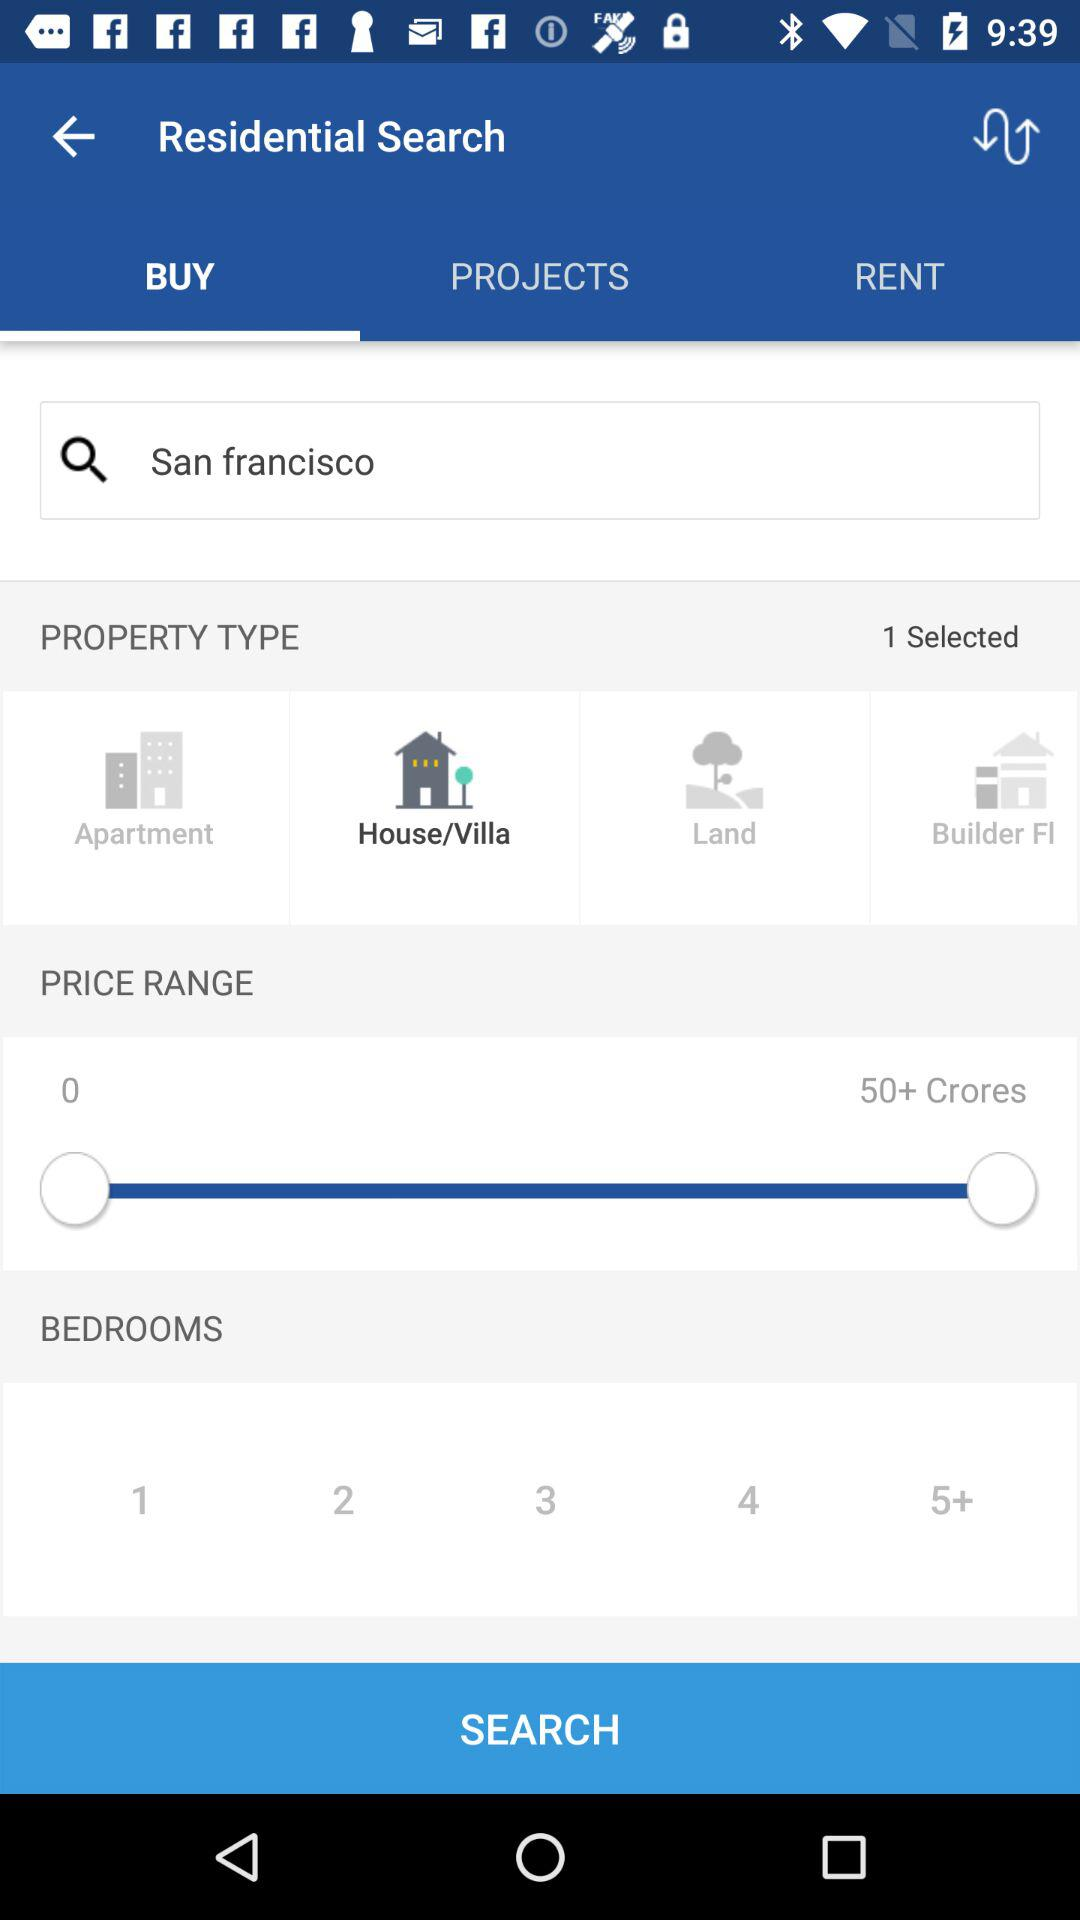What is the location inputted into the search bar? The location is San Francisco. 